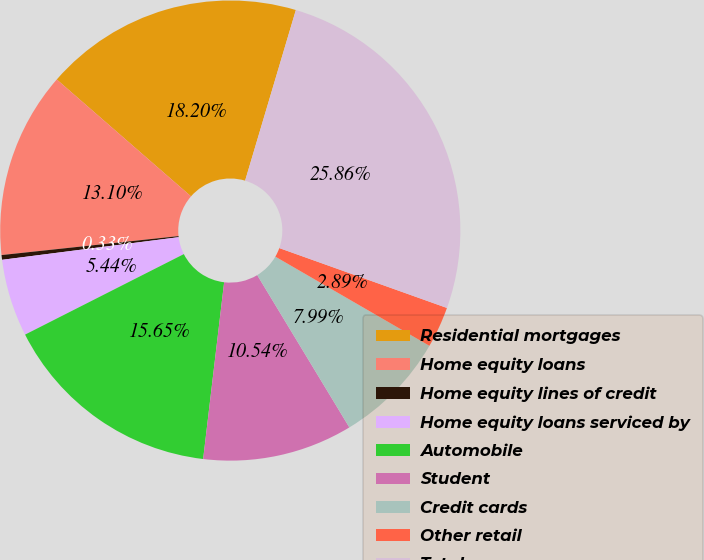Convert chart to OTSL. <chart><loc_0><loc_0><loc_500><loc_500><pie_chart><fcel>Residential mortgages<fcel>Home equity loans<fcel>Home equity lines of credit<fcel>Home equity loans serviced by<fcel>Automobile<fcel>Student<fcel>Credit cards<fcel>Other retail<fcel>Total<nl><fcel>18.2%<fcel>13.1%<fcel>0.33%<fcel>5.44%<fcel>15.65%<fcel>10.54%<fcel>7.99%<fcel>2.89%<fcel>25.86%<nl></chart> 